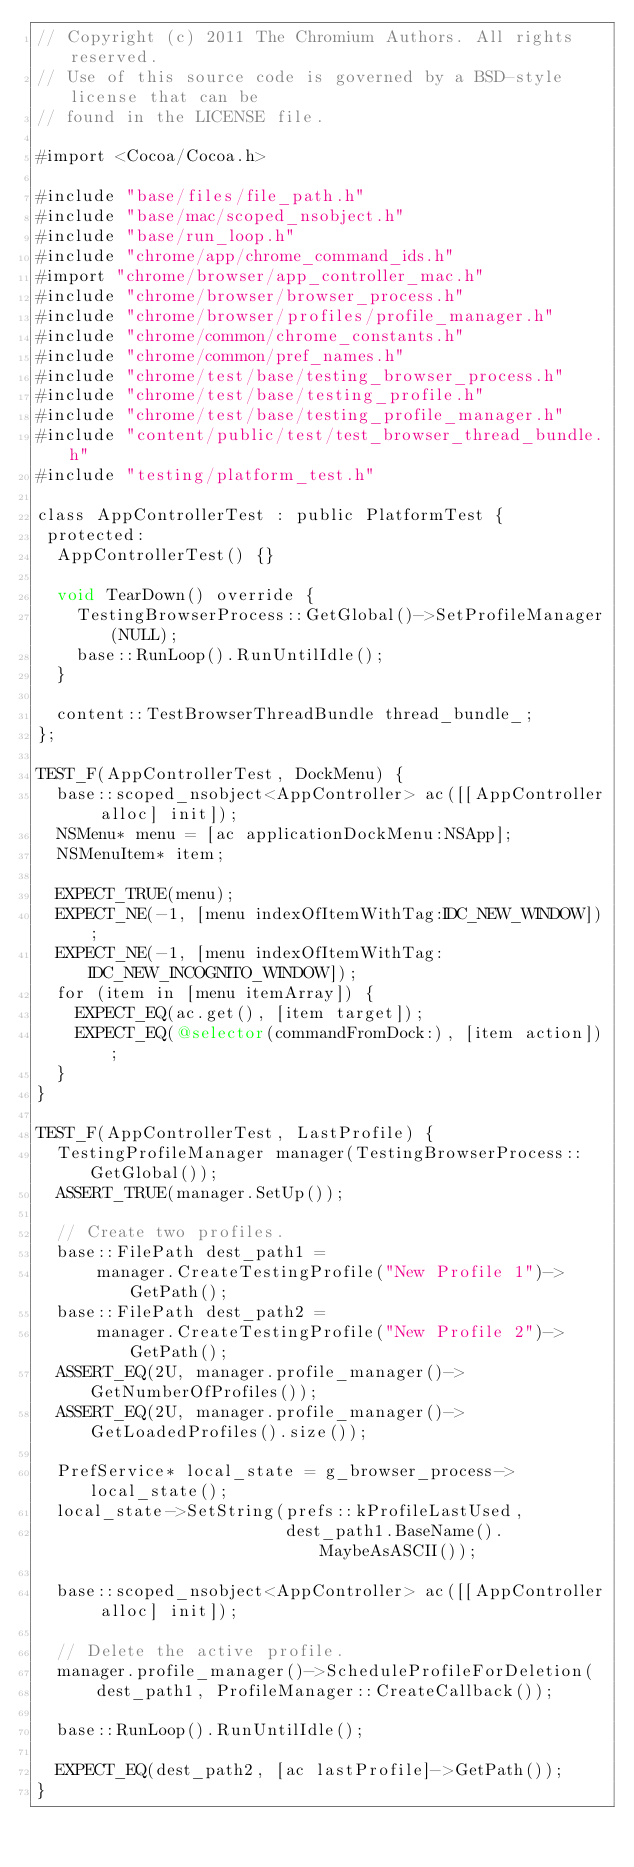Convert code to text. <code><loc_0><loc_0><loc_500><loc_500><_ObjectiveC_>// Copyright (c) 2011 The Chromium Authors. All rights reserved.
// Use of this source code is governed by a BSD-style license that can be
// found in the LICENSE file.

#import <Cocoa/Cocoa.h>

#include "base/files/file_path.h"
#include "base/mac/scoped_nsobject.h"
#include "base/run_loop.h"
#include "chrome/app/chrome_command_ids.h"
#import "chrome/browser/app_controller_mac.h"
#include "chrome/browser/browser_process.h"
#include "chrome/browser/profiles/profile_manager.h"
#include "chrome/common/chrome_constants.h"
#include "chrome/common/pref_names.h"
#include "chrome/test/base/testing_browser_process.h"
#include "chrome/test/base/testing_profile.h"
#include "chrome/test/base/testing_profile_manager.h"
#include "content/public/test/test_browser_thread_bundle.h"
#include "testing/platform_test.h"

class AppControllerTest : public PlatformTest {
 protected:
  AppControllerTest() {}

  void TearDown() override {
    TestingBrowserProcess::GetGlobal()->SetProfileManager(NULL);
    base::RunLoop().RunUntilIdle();
  }

  content::TestBrowserThreadBundle thread_bundle_;
};

TEST_F(AppControllerTest, DockMenu) {
  base::scoped_nsobject<AppController> ac([[AppController alloc] init]);
  NSMenu* menu = [ac applicationDockMenu:NSApp];
  NSMenuItem* item;

  EXPECT_TRUE(menu);
  EXPECT_NE(-1, [menu indexOfItemWithTag:IDC_NEW_WINDOW]);
  EXPECT_NE(-1, [menu indexOfItemWithTag:IDC_NEW_INCOGNITO_WINDOW]);
  for (item in [menu itemArray]) {
    EXPECT_EQ(ac.get(), [item target]);
    EXPECT_EQ(@selector(commandFromDock:), [item action]);
  }
}

TEST_F(AppControllerTest, LastProfile) {
  TestingProfileManager manager(TestingBrowserProcess::GetGlobal());
  ASSERT_TRUE(manager.SetUp());

  // Create two profiles.
  base::FilePath dest_path1 =
      manager.CreateTestingProfile("New Profile 1")->GetPath();
  base::FilePath dest_path2 =
      manager.CreateTestingProfile("New Profile 2")->GetPath();
  ASSERT_EQ(2U, manager.profile_manager()->GetNumberOfProfiles());
  ASSERT_EQ(2U, manager.profile_manager()->GetLoadedProfiles().size());

  PrefService* local_state = g_browser_process->local_state();
  local_state->SetString(prefs::kProfileLastUsed,
                         dest_path1.BaseName().MaybeAsASCII());

  base::scoped_nsobject<AppController> ac([[AppController alloc] init]);

  // Delete the active profile.
  manager.profile_manager()->ScheduleProfileForDeletion(
      dest_path1, ProfileManager::CreateCallback());

  base::RunLoop().RunUntilIdle();

  EXPECT_EQ(dest_path2, [ac lastProfile]->GetPath());
}
</code> 